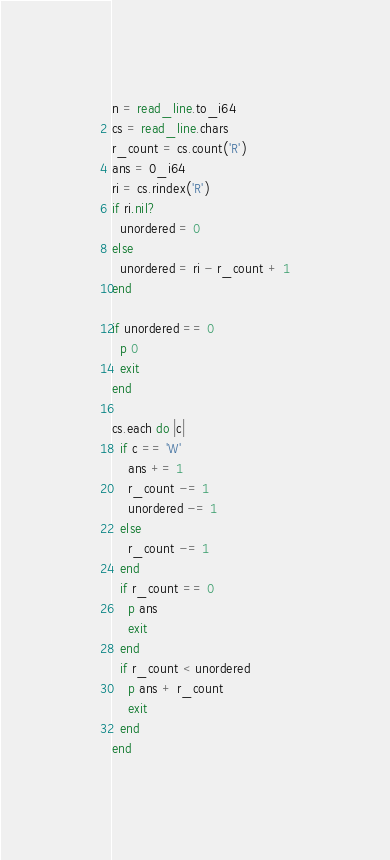Convert code to text. <code><loc_0><loc_0><loc_500><loc_500><_Crystal_>n = read_line.to_i64
cs = read_line.chars
r_count = cs.count('R')
ans = 0_i64
ri = cs.rindex('R')
if ri.nil?
  unordered = 0
else
  unordered = ri - r_count + 1
end

if unordered == 0
  p 0
  exit
end

cs.each do |c|
  if c == 'W'
    ans += 1
    r_count -= 1
    unordered -= 1
  else
    r_count -= 1
  end
  if r_count == 0
    p ans
    exit
  end
  if r_count < unordered
    p ans + r_count
    exit
  end
end</code> 